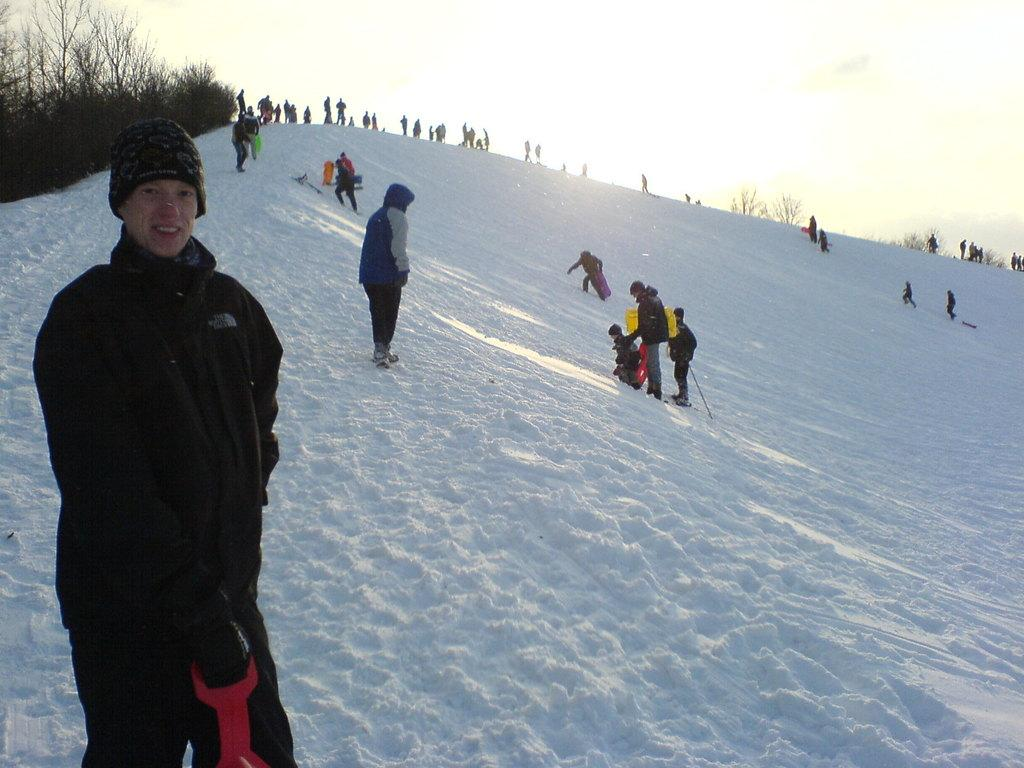What can be seen in the image? There are people standing in the image. What are some of the people wearing? Some of the people are wearing caps. What is the condition of the ground in the image? There is snow on the ground. What type of vegetation is present in the image? There are trees in the image. How would you describe the sky in the image? The sky is cloudy. What type of toothbrush is being used to clean the trees in the image? There is no toothbrush present in the image, and the trees are not being cleaned. 